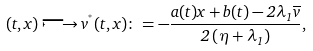Convert formula to latex. <formula><loc_0><loc_0><loc_500><loc_500>( t , x ) \longmapsto v ^ { ^ { * } } ( t , x ) \colon = - \frac { a ( t ) x + b ( t ) - 2 \lambda _ { 1 } \overline { v } } { 2 \left ( \eta + \lambda _ { 1 } \right ) } ,</formula> 